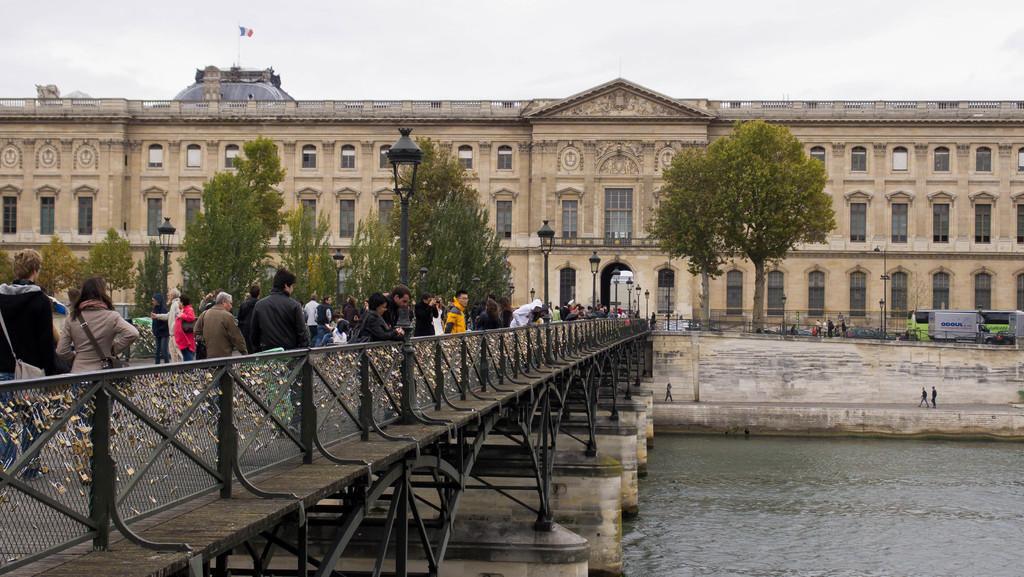Can you describe this image briefly? In this picture there are people and we can see bridgewater, wall and light poles. In the background of the image we can see building, vehicle, trees and sky. 